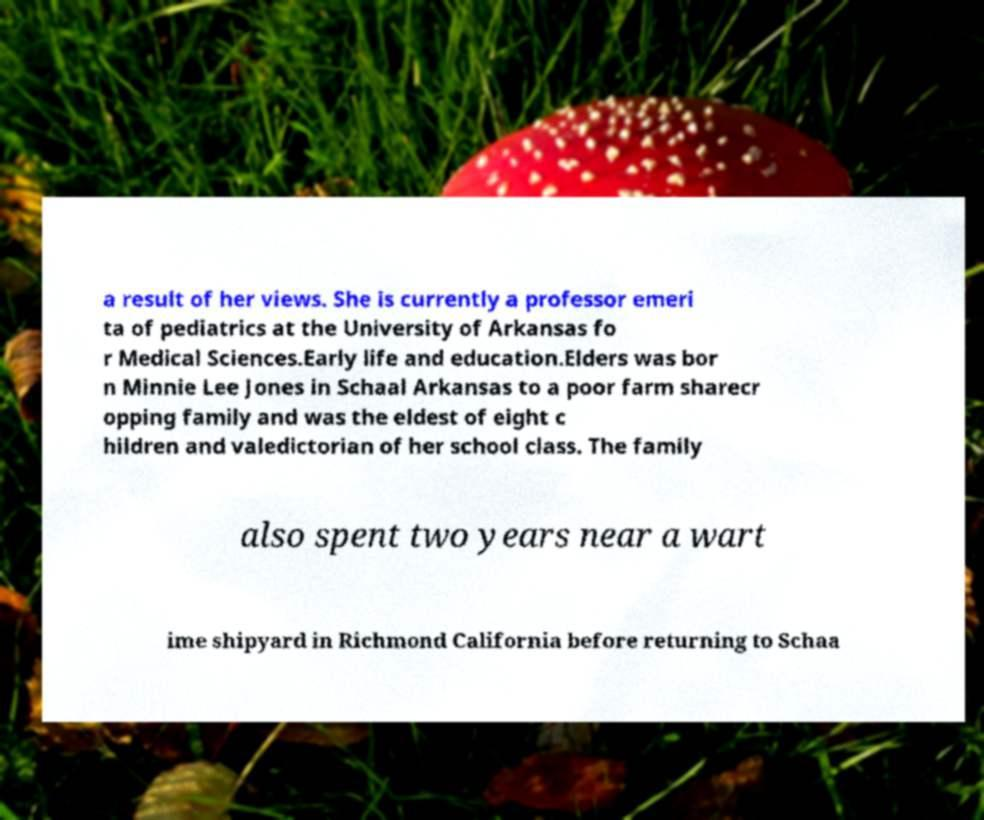Please read and relay the text visible in this image. What does it say? a result of her views. She is currently a professor emeri ta of pediatrics at the University of Arkansas fo r Medical Sciences.Early life and education.Elders was bor n Minnie Lee Jones in Schaal Arkansas to a poor farm sharecr opping family and was the eldest of eight c hildren and valedictorian of her school class. The family also spent two years near a wart ime shipyard in Richmond California before returning to Schaa 